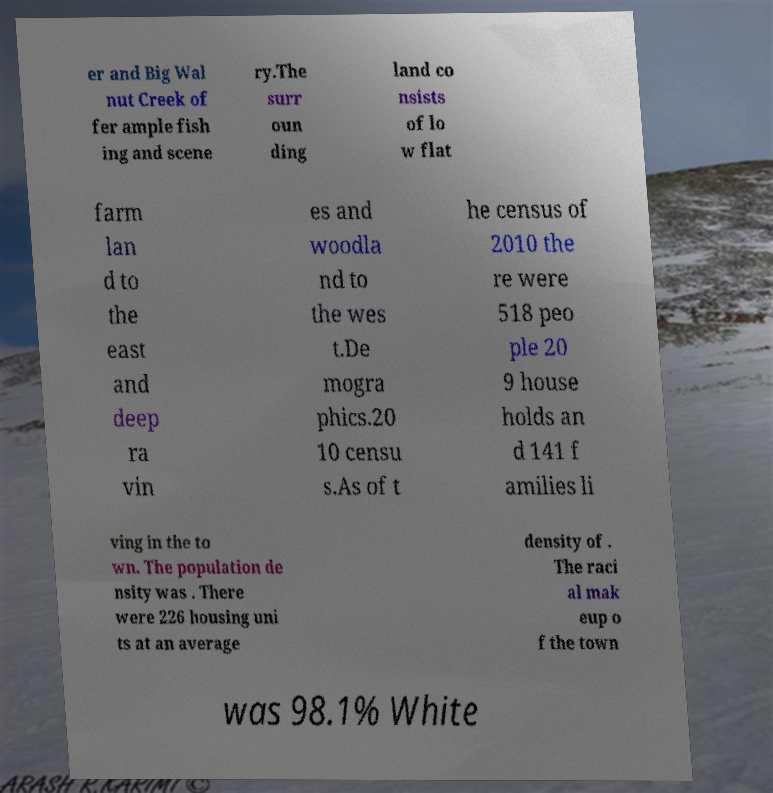What messages or text are displayed in this image? I need them in a readable, typed format. er and Big Wal nut Creek of fer ample fish ing and scene ry.The surr oun ding land co nsists of lo w flat farm lan d to the east and deep ra vin es and woodla nd to the wes t.De mogra phics.20 10 censu s.As of t he census of 2010 the re were 518 peo ple 20 9 house holds an d 141 f amilies li ving in the to wn. The population de nsity was . There were 226 housing uni ts at an average density of . The raci al mak eup o f the town was 98.1% White 